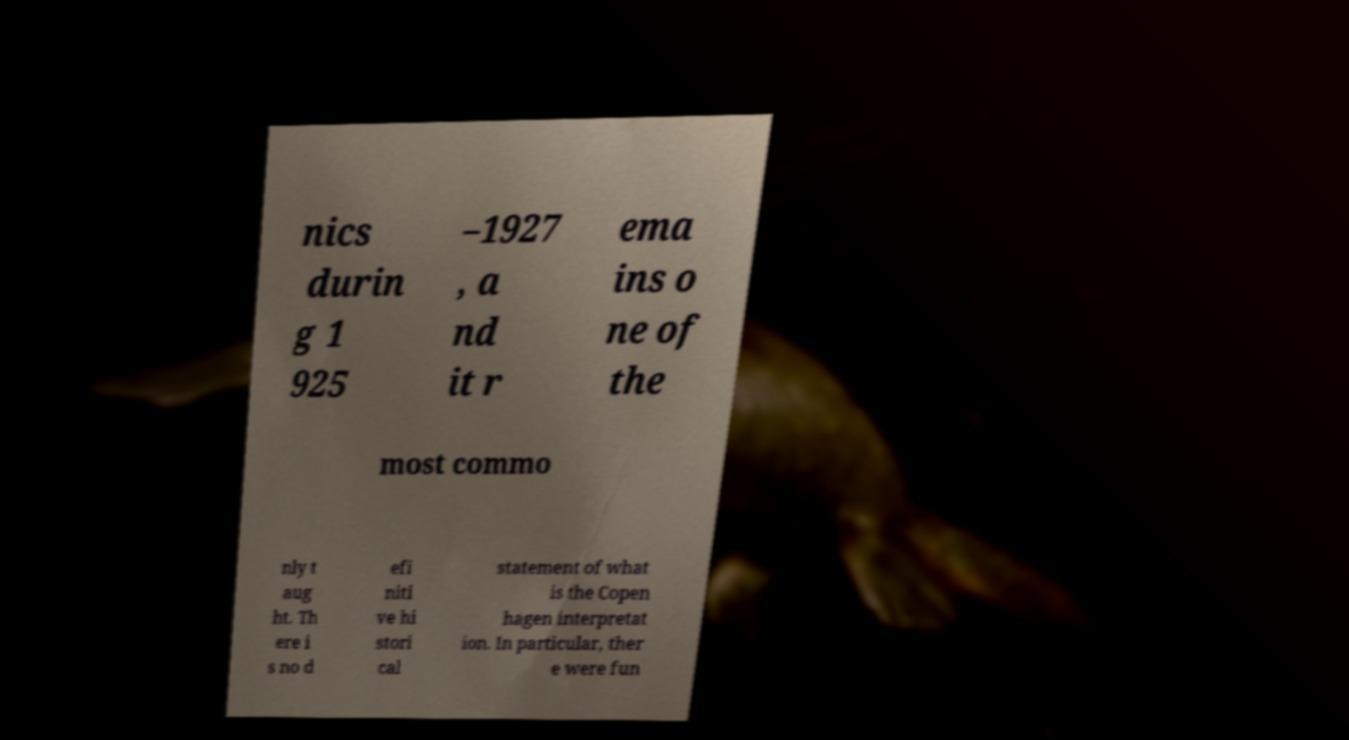Please identify and transcribe the text found in this image. nics durin g 1 925 –1927 , a nd it r ema ins o ne of the most commo nly t aug ht. Th ere i s no d efi niti ve hi stori cal statement of what is the Copen hagen interpretat ion. In particular, ther e were fun 